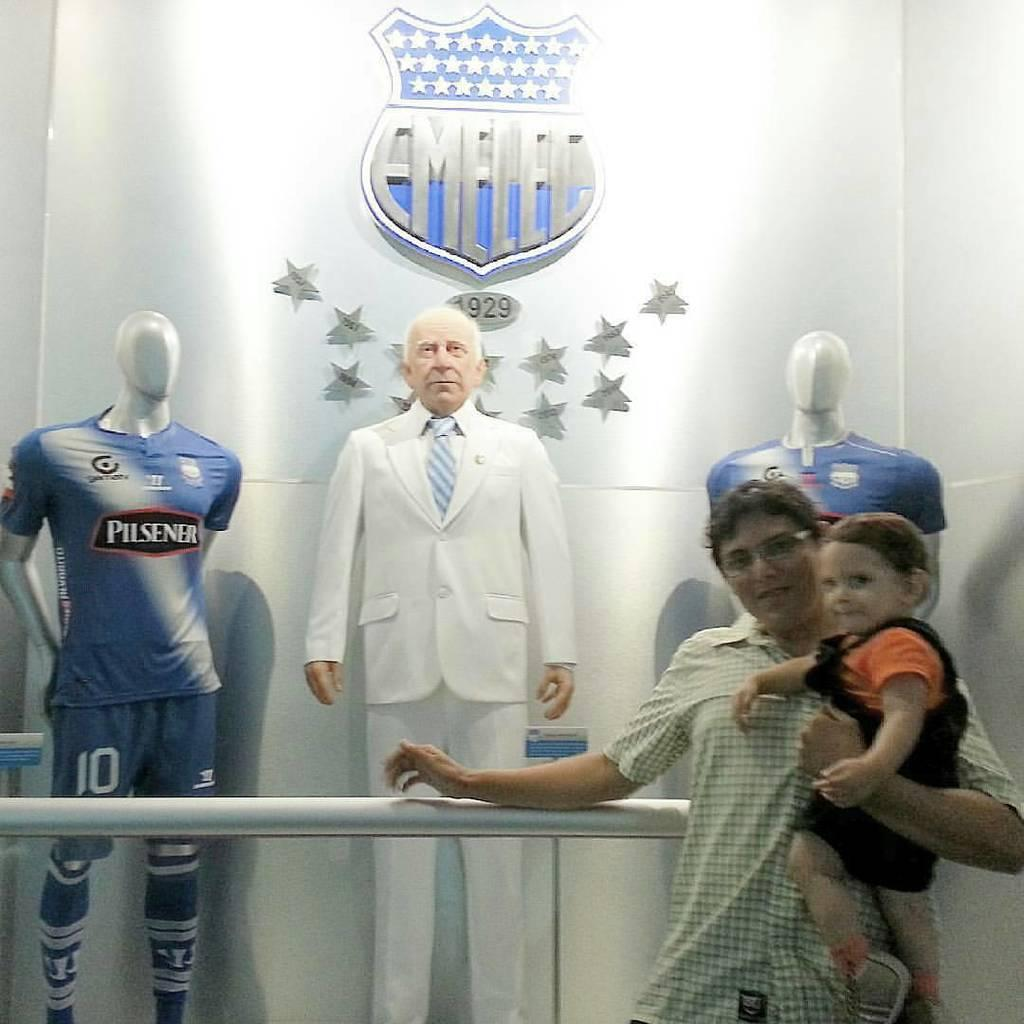<image>
Share a concise interpretation of the image provided. one of the models is wearing a Pilsener jersey 